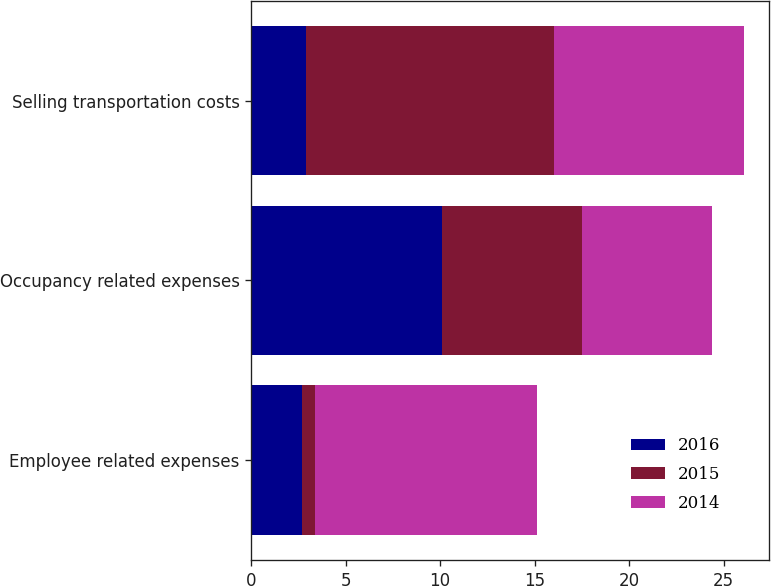Convert chart to OTSL. <chart><loc_0><loc_0><loc_500><loc_500><stacked_bar_chart><ecel><fcel>Employee related expenses<fcel>Occupancy related expenses<fcel>Selling transportation costs<nl><fcel>2016<fcel>2.7<fcel>10.1<fcel>2.9<nl><fcel>2015<fcel>0.7<fcel>7.4<fcel>13.1<nl><fcel>2014<fcel>11.7<fcel>6.9<fcel>10.1<nl></chart> 